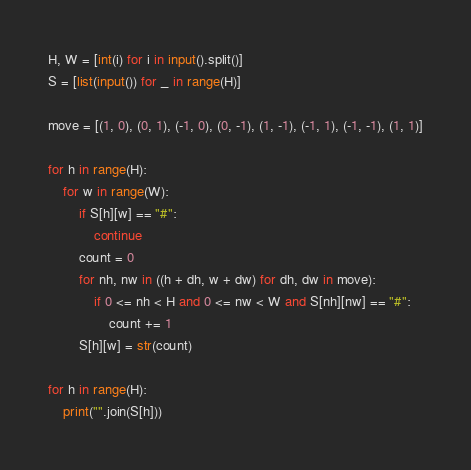Convert code to text. <code><loc_0><loc_0><loc_500><loc_500><_Python_>H, W = [int(i) for i in input().split()]
S = [list(input()) for _ in range(H)]

move = [(1, 0), (0, 1), (-1, 0), (0, -1), (1, -1), (-1, 1), (-1, -1), (1, 1)]

for h in range(H):
    for w in range(W):
        if S[h][w] == "#":
            continue
        count = 0
        for nh, nw in ((h + dh, w + dw) for dh, dw in move):
            if 0 <= nh < H and 0 <= nw < W and S[nh][nw] == "#":
                count += 1
        S[h][w] = str(count)

for h in range(H):
    print("".join(S[h]))</code> 